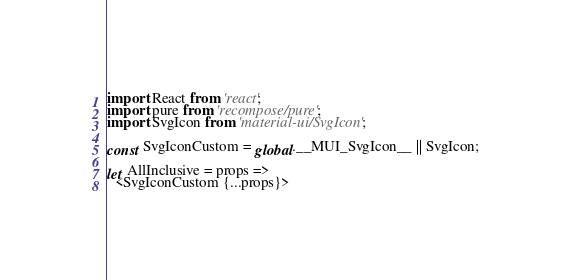<code> <loc_0><loc_0><loc_500><loc_500><_JavaScript_>import React from 'react';
import pure from 'recompose/pure';
import SvgIcon from 'material-ui/SvgIcon';

const SvgIconCustom = global.__MUI_SvgIcon__ || SvgIcon;

let AllInclusive = props =>
  <SvgIconCustom {...props}></code> 